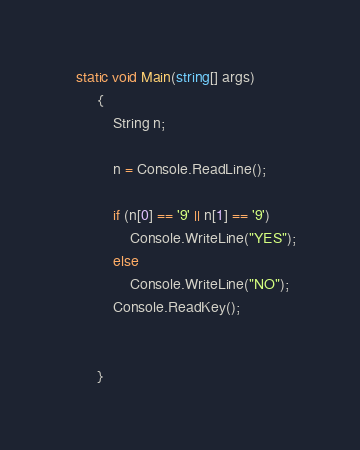<code> <loc_0><loc_0><loc_500><loc_500><_C#_>   static void Main(string[] args)
        {
            String n;

            n = Console.ReadLine();

            if (n[0] == '9' || n[1] == '9')
                Console.WriteLine("YES");
            else
                Console.WriteLine("NO");
            Console.ReadKey();


        }</code> 